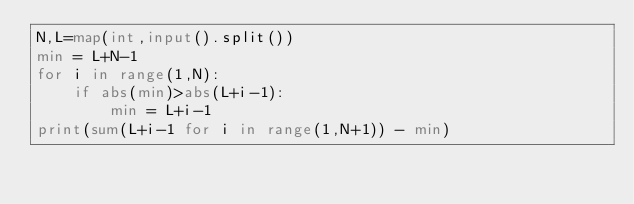Convert code to text. <code><loc_0><loc_0><loc_500><loc_500><_Python_>N,L=map(int,input().split())
min = L+N-1
for i in range(1,N):
    if abs(min)>abs(L+i-1):
        min = L+i-1
print(sum(L+i-1 for i in range(1,N+1)) - min)</code> 